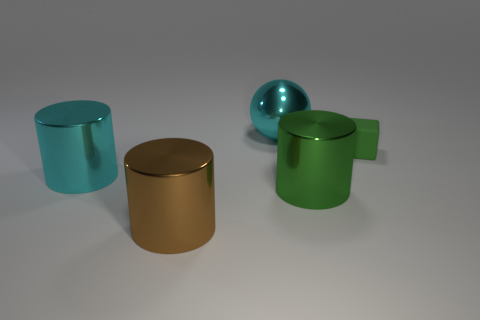Is there a big cyan shiny thing that has the same shape as the big green metal object?
Make the answer very short. Yes. There is a cylinder that is to the right of the brown cylinder; is its size the same as the rubber thing?
Your answer should be compact. No. What number of metallic objects are both behind the green rubber thing and in front of the cyan metallic sphere?
Keep it short and to the point. 0. Is the big brown cylinder made of the same material as the large cyan cylinder?
Your response must be concise. Yes. What is the shape of the object that is behind the green object that is on the right side of the green metallic thing that is behind the large brown cylinder?
Make the answer very short. Sphere. There is a thing that is both on the right side of the big cyan metal sphere and on the left side of the tiny green rubber cube; what material is it?
Offer a terse response. Metal. What color is the large thing that is behind the cyan thing in front of the big cyan metal thing behind the large cyan shiny cylinder?
Make the answer very short. Cyan. How many green things are either tiny matte cylinders or big objects?
Offer a terse response. 1. What number of other things are the same size as the rubber block?
Offer a very short reply. 0. How many large blue cubes are there?
Ensure brevity in your answer.  0. 